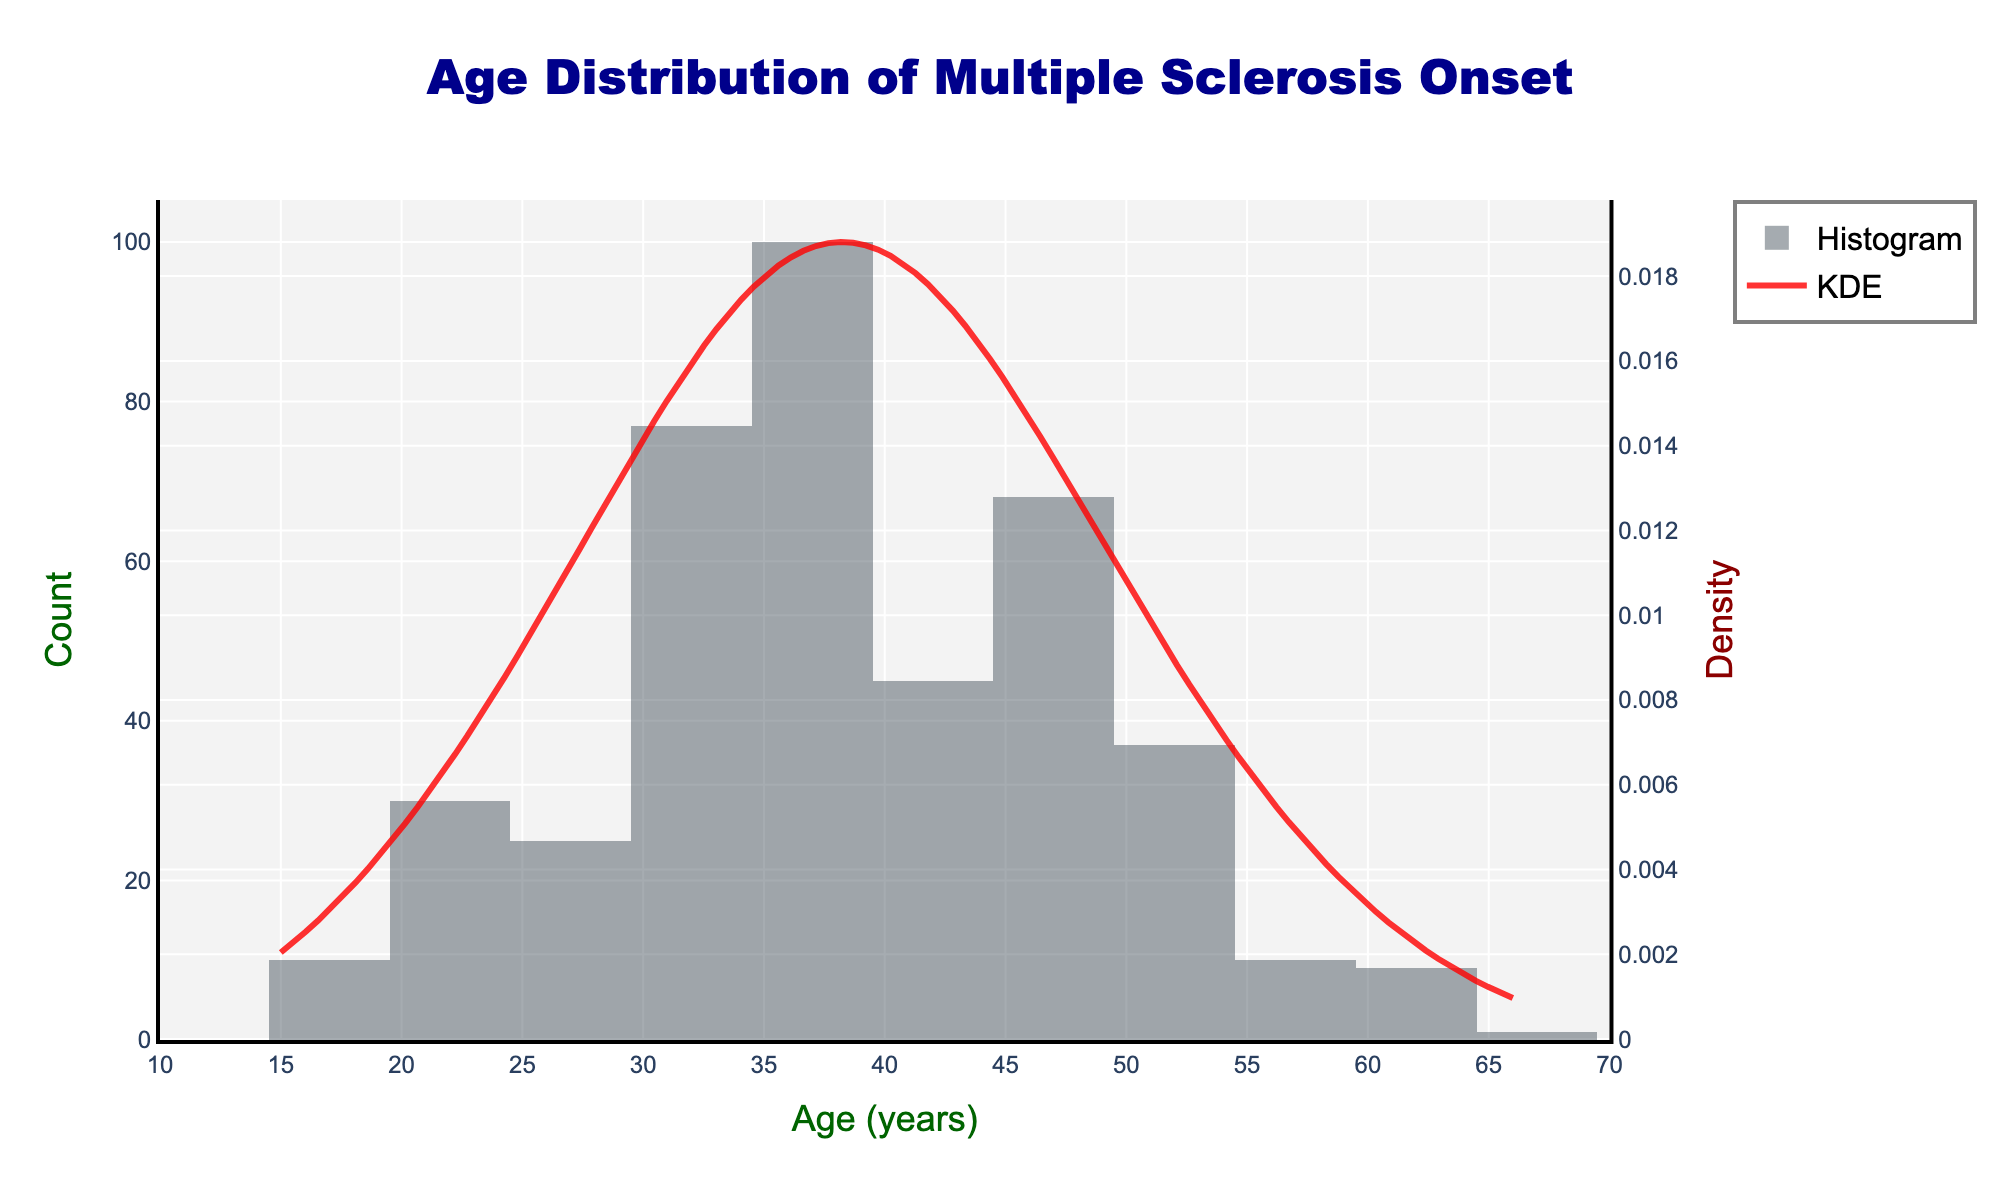What is the title of the figure? The title is displayed at the top of the figure, it is shown clearly in large, bold text.
Answer: Age Distribution of Multiple Sclerosis Onset What is the age range covered by the x-axis? The x-axis range is specified from 10 to 70 years and is marked with ticks in increments of 5 years.
Answer: 10 to 70 years What color represents the KDE curve? The KDE curve is displayed as a line and its color is visually distinct, being a shade of red.
Answer: Red At what age is the peak density of multiple sclerosis onset? The KDE curve shows the density distribution and the age with the highest KDE value indicates the peak density.
Answer: 39 years What is the highest count of patients at a particular age? The histogram shows the count of patients at each age, and the tallest bar represents the highest count, which is at age 39.
Answer: 52 How does the count of patients at age 30 compare to the count at age 60? The histogram shows the count of patients, and by examining the heights of the bars for ages 30 and 60, one can compare the counts directly.
Answer: Age 30 has a higher count than age 60 How does the density of patients at age 21 compare to age 54? To compare densities, examine the height of the KDE curve at ages 21 and 54; the curve is higher at age 21.
Answer: Higher at age 21 What age range shows a significant decline in patient count after the peak? Observe the histogram after the peak at age 39, focusing on the sharp decline in bar heights from ages 42 onward to somewhere around 60.
Answer: 42 to 60 years Between which two ages does the KDE curve drop the fastest after the peak? Examine the steepness of the decline in the KDE curve just after it peaks at age 39, focusing on the section showing the steepest decline.
Answer: 39 and 45 years What is the visual appearance of the plot background and its color? The plot background is described, which is a light gray shade that enhances the visibility of the histogram and KDE curve.
Answer: Light gray background 